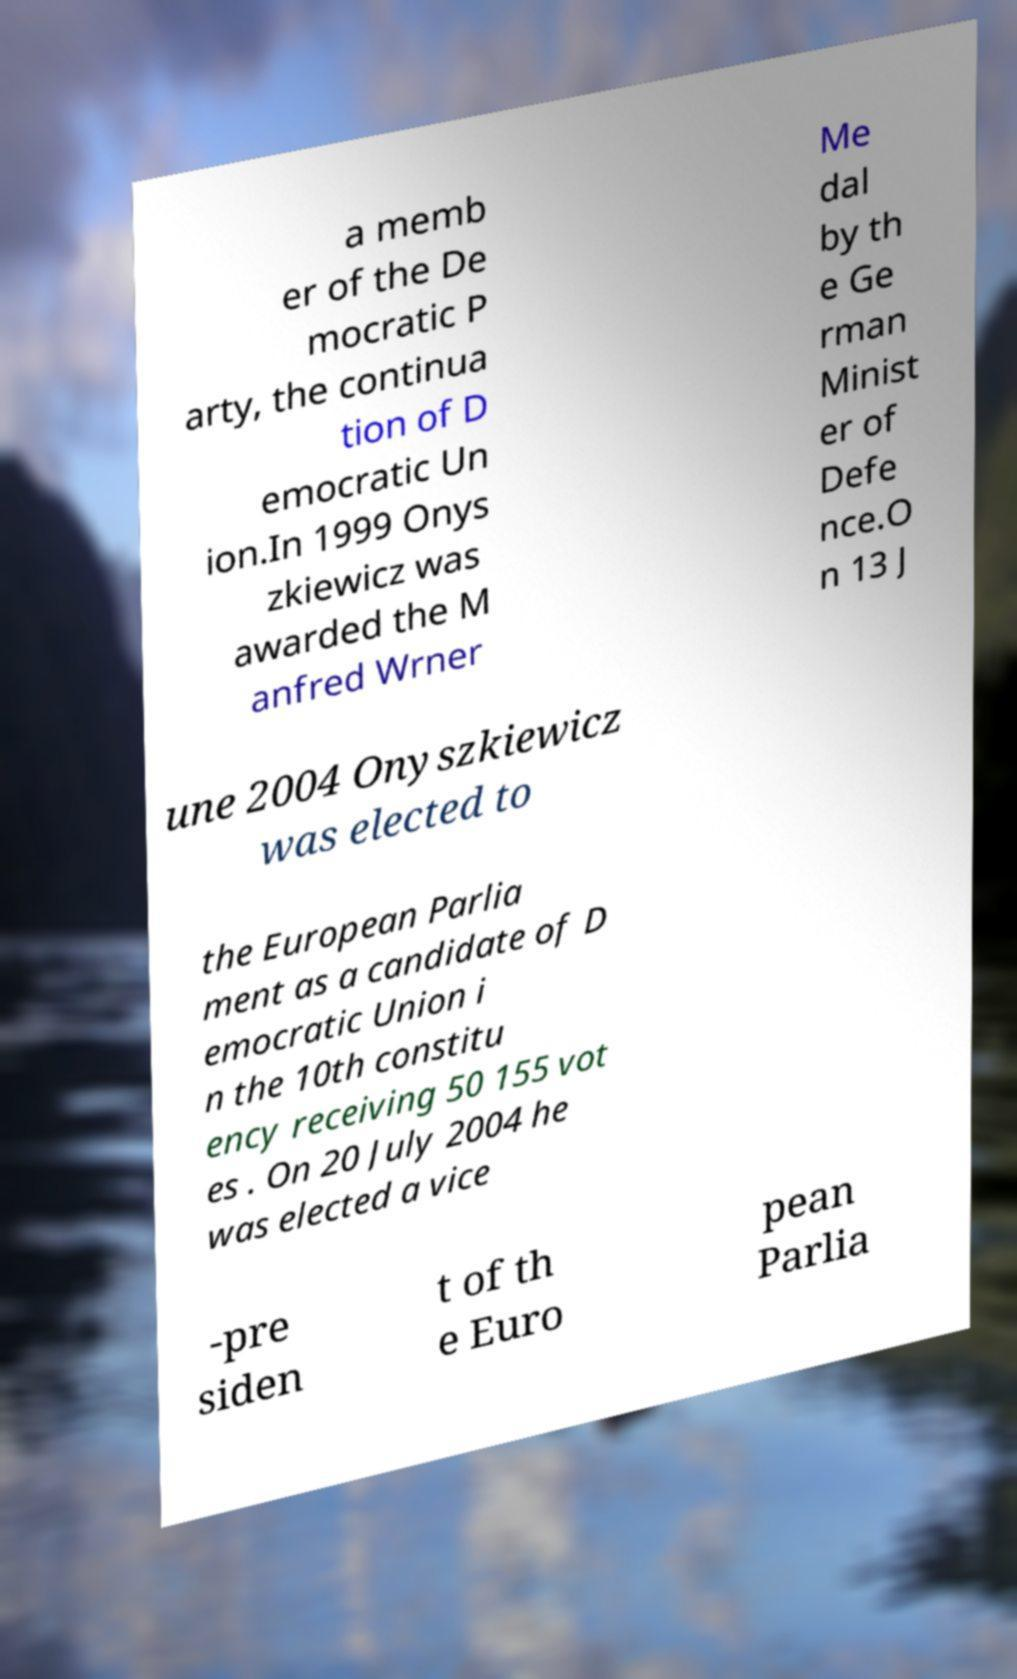What messages or text are displayed in this image? I need them in a readable, typed format. a memb er of the De mocratic P arty, the continua tion of D emocratic Un ion.In 1999 Onys zkiewicz was awarded the M anfred Wrner Me dal by th e Ge rman Minist er of Defe nce.O n 13 J une 2004 Onyszkiewicz was elected to the European Parlia ment as a candidate of D emocratic Union i n the 10th constitu ency receiving 50 155 vot es . On 20 July 2004 he was elected a vice -pre siden t of th e Euro pean Parlia 